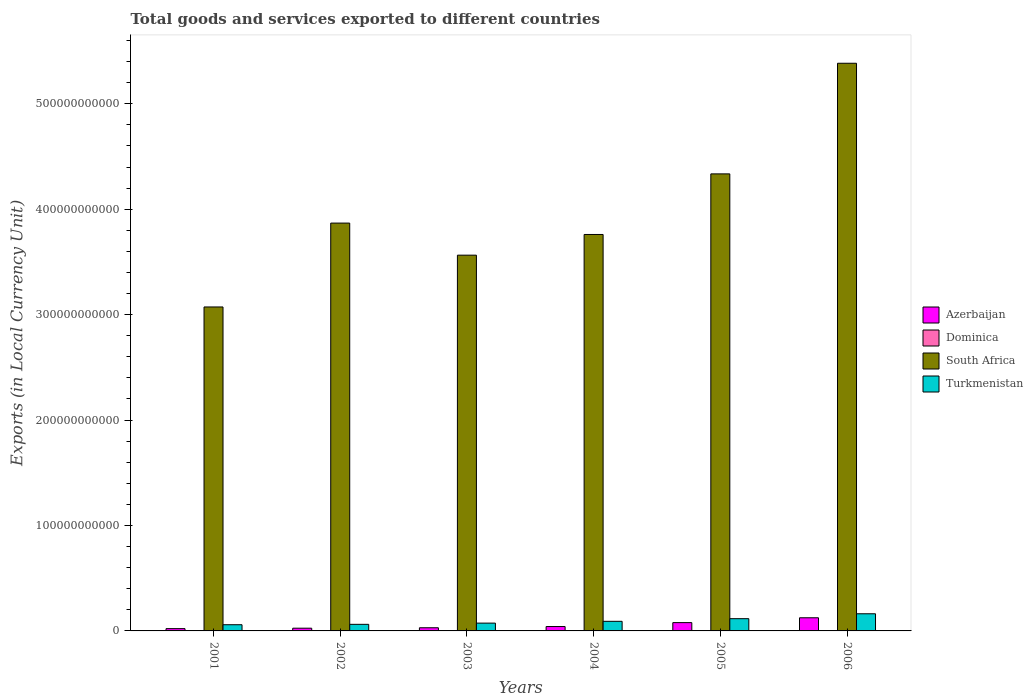How many groups of bars are there?
Make the answer very short. 6. How many bars are there on the 4th tick from the right?
Keep it short and to the point. 4. What is the label of the 6th group of bars from the left?
Keep it short and to the point. 2006. What is the Amount of goods and services exports in Azerbaijan in 2004?
Give a very brief answer. 4.16e+09. Across all years, what is the maximum Amount of goods and services exports in Azerbaijan?
Your answer should be compact. 1.25e+1. Across all years, what is the minimum Amount of goods and services exports in Azerbaijan?
Offer a terse response. 2.18e+09. In which year was the Amount of goods and services exports in Azerbaijan minimum?
Your response must be concise. 2001. What is the total Amount of goods and services exports in Azerbaijan in the graph?
Provide a succinct answer. 3.23e+1. What is the difference between the Amount of goods and services exports in Turkmenistan in 2002 and that in 2003?
Give a very brief answer. -1.16e+09. What is the difference between the Amount of goods and services exports in South Africa in 2005 and the Amount of goods and services exports in Azerbaijan in 2001?
Ensure brevity in your answer.  4.31e+11. What is the average Amount of goods and services exports in Azerbaijan per year?
Ensure brevity in your answer.  5.38e+09. In the year 2006, what is the difference between the Amount of goods and services exports in Dominica and Amount of goods and services exports in South Africa?
Make the answer very short. -5.38e+11. In how many years, is the Amount of goods and services exports in Turkmenistan greater than 260000000000 LCU?
Your answer should be compact. 0. What is the ratio of the Amount of goods and services exports in Azerbaijan in 2002 to that in 2005?
Offer a terse response. 0.33. Is the Amount of goods and services exports in Dominica in 2001 less than that in 2004?
Ensure brevity in your answer.  Yes. What is the difference between the highest and the second highest Amount of goods and services exports in Turkmenistan?
Your answer should be very brief. 4.65e+09. What is the difference between the highest and the lowest Amount of goods and services exports in Turkmenistan?
Give a very brief answer. 1.04e+1. Is it the case that in every year, the sum of the Amount of goods and services exports in South Africa and Amount of goods and services exports in Azerbaijan is greater than the sum of Amount of goods and services exports in Turkmenistan and Amount of goods and services exports in Dominica?
Your response must be concise. No. What does the 4th bar from the left in 2004 represents?
Your answer should be compact. Turkmenistan. What does the 1st bar from the right in 2003 represents?
Your response must be concise. Turkmenistan. Is it the case that in every year, the sum of the Amount of goods and services exports in Dominica and Amount of goods and services exports in Turkmenistan is greater than the Amount of goods and services exports in South Africa?
Provide a succinct answer. No. Are all the bars in the graph horizontal?
Provide a succinct answer. No. How many years are there in the graph?
Offer a very short reply. 6. What is the difference between two consecutive major ticks on the Y-axis?
Provide a short and direct response. 1.00e+11. Are the values on the major ticks of Y-axis written in scientific E-notation?
Make the answer very short. No. Does the graph contain any zero values?
Make the answer very short. No. Where does the legend appear in the graph?
Your answer should be compact. Center right. What is the title of the graph?
Keep it short and to the point. Total goods and services exported to different countries. Does "Congo (Republic)" appear as one of the legend labels in the graph?
Make the answer very short. No. What is the label or title of the X-axis?
Keep it short and to the point. Years. What is the label or title of the Y-axis?
Keep it short and to the point. Exports (in Local Currency Unit). What is the Exports (in Local Currency Unit) in Azerbaijan in 2001?
Offer a terse response. 2.18e+09. What is the Exports (in Local Currency Unit) in Dominica in 2001?
Offer a terse response. 3.27e+08. What is the Exports (in Local Currency Unit) of South Africa in 2001?
Keep it short and to the point. 3.07e+11. What is the Exports (in Local Currency Unit) in Turkmenistan in 2001?
Offer a very short reply. 5.87e+09. What is the Exports (in Local Currency Unit) of Azerbaijan in 2002?
Offer a terse response. 2.59e+09. What is the Exports (in Local Currency Unit) in Dominica in 2002?
Ensure brevity in your answer.  3.33e+08. What is the Exports (in Local Currency Unit) in South Africa in 2002?
Your answer should be compact. 3.87e+11. What is the Exports (in Local Currency Unit) in Turkmenistan in 2002?
Your response must be concise. 6.25e+09. What is the Exports (in Local Currency Unit) in Azerbaijan in 2003?
Ensure brevity in your answer.  3.00e+09. What is the Exports (in Local Currency Unit) of Dominica in 2003?
Provide a short and direct response. 3.20e+08. What is the Exports (in Local Currency Unit) in South Africa in 2003?
Offer a terse response. 3.56e+11. What is the Exports (in Local Currency Unit) in Turkmenistan in 2003?
Keep it short and to the point. 7.40e+09. What is the Exports (in Local Currency Unit) of Azerbaijan in 2004?
Keep it short and to the point. 4.16e+09. What is the Exports (in Local Currency Unit) of Dominica in 2004?
Offer a very short reply. 3.52e+08. What is the Exports (in Local Currency Unit) in South Africa in 2004?
Offer a very short reply. 3.76e+11. What is the Exports (in Local Currency Unit) of Turkmenistan in 2004?
Your answer should be very brief. 9.10e+09. What is the Exports (in Local Currency Unit) of Azerbaijan in 2005?
Your response must be concise. 7.88e+09. What is the Exports (in Local Currency Unit) in Dominica in 2005?
Your response must be concise. 3.49e+08. What is the Exports (in Local Currency Unit) in South Africa in 2005?
Keep it short and to the point. 4.34e+11. What is the Exports (in Local Currency Unit) of Turkmenistan in 2005?
Offer a very short reply. 1.16e+1. What is the Exports (in Local Currency Unit) in Azerbaijan in 2006?
Provide a short and direct response. 1.25e+1. What is the Exports (in Local Currency Unit) in Dominica in 2006?
Provide a succinct answer. 3.90e+08. What is the Exports (in Local Currency Unit) of South Africa in 2006?
Your answer should be compact. 5.38e+11. What is the Exports (in Local Currency Unit) of Turkmenistan in 2006?
Your response must be concise. 1.63e+1. Across all years, what is the maximum Exports (in Local Currency Unit) in Azerbaijan?
Your answer should be very brief. 1.25e+1. Across all years, what is the maximum Exports (in Local Currency Unit) in Dominica?
Offer a terse response. 3.90e+08. Across all years, what is the maximum Exports (in Local Currency Unit) of South Africa?
Keep it short and to the point. 5.38e+11. Across all years, what is the maximum Exports (in Local Currency Unit) of Turkmenistan?
Keep it short and to the point. 1.63e+1. Across all years, what is the minimum Exports (in Local Currency Unit) in Azerbaijan?
Give a very brief answer. 2.18e+09. Across all years, what is the minimum Exports (in Local Currency Unit) of Dominica?
Offer a very short reply. 3.20e+08. Across all years, what is the minimum Exports (in Local Currency Unit) of South Africa?
Make the answer very short. 3.07e+11. Across all years, what is the minimum Exports (in Local Currency Unit) in Turkmenistan?
Offer a terse response. 5.87e+09. What is the total Exports (in Local Currency Unit) in Azerbaijan in the graph?
Provide a succinct answer. 3.23e+1. What is the total Exports (in Local Currency Unit) in Dominica in the graph?
Your response must be concise. 2.07e+09. What is the total Exports (in Local Currency Unit) of South Africa in the graph?
Your response must be concise. 2.40e+12. What is the total Exports (in Local Currency Unit) in Turkmenistan in the graph?
Keep it short and to the point. 5.65e+1. What is the difference between the Exports (in Local Currency Unit) in Azerbaijan in 2001 and that in 2002?
Offer a very short reply. -4.18e+08. What is the difference between the Exports (in Local Currency Unit) in Dominica in 2001 and that in 2002?
Your response must be concise. -5.18e+06. What is the difference between the Exports (in Local Currency Unit) of South Africa in 2001 and that in 2002?
Provide a succinct answer. -7.96e+1. What is the difference between the Exports (in Local Currency Unit) in Turkmenistan in 2001 and that in 2002?
Offer a very short reply. -3.78e+08. What is the difference between the Exports (in Local Currency Unit) of Azerbaijan in 2001 and that in 2003?
Ensure brevity in your answer.  -8.27e+08. What is the difference between the Exports (in Local Currency Unit) of Dominica in 2001 and that in 2003?
Your answer should be very brief. 7.66e+06. What is the difference between the Exports (in Local Currency Unit) in South Africa in 2001 and that in 2003?
Give a very brief answer. -4.91e+1. What is the difference between the Exports (in Local Currency Unit) in Turkmenistan in 2001 and that in 2003?
Your answer should be very brief. -1.53e+09. What is the difference between the Exports (in Local Currency Unit) of Azerbaijan in 2001 and that in 2004?
Make the answer very short. -1.99e+09. What is the difference between the Exports (in Local Currency Unit) in Dominica in 2001 and that in 2004?
Your answer should be compact. -2.49e+07. What is the difference between the Exports (in Local Currency Unit) in South Africa in 2001 and that in 2004?
Offer a terse response. -6.88e+1. What is the difference between the Exports (in Local Currency Unit) in Turkmenistan in 2001 and that in 2004?
Your answer should be very brief. -3.23e+09. What is the difference between the Exports (in Local Currency Unit) of Azerbaijan in 2001 and that in 2005?
Keep it short and to the point. -5.71e+09. What is the difference between the Exports (in Local Currency Unit) in Dominica in 2001 and that in 2005?
Your answer should be very brief. -2.16e+07. What is the difference between the Exports (in Local Currency Unit) of South Africa in 2001 and that in 2005?
Ensure brevity in your answer.  -1.26e+11. What is the difference between the Exports (in Local Currency Unit) of Turkmenistan in 2001 and that in 2005?
Make the answer very short. -5.75e+09. What is the difference between the Exports (in Local Currency Unit) of Azerbaijan in 2001 and that in 2006?
Offer a very short reply. -1.03e+1. What is the difference between the Exports (in Local Currency Unit) in Dominica in 2001 and that in 2006?
Keep it short and to the point. -6.26e+07. What is the difference between the Exports (in Local Currency Unit) of South Africa in 2001 and that in 2006?
Your answer should be compact. -2.31e+11. What is the difference between the Exports (in Local Currency Unit) of Turkmenistan in 2001 and that in 2006?
Make the answer very short. -1.04e+1. What is the difference between the Exports (in Local Currency Unit) in Azerbaijan in 2002 and that in 2003?
Provide a short and direct response. -4.09e+08. What is the difference between the Exports (in Local Currency Unit) in Dominica in 2002 and that in 2003?
Offer a terse response. 1.28e+07. What is the difference between the Exports (in Local Currency Unit) in South Africa in 2002 and that in 2003?
Ensure brevity in your answer.  3.04e+1. What is the difference between the Exports (in Local Currency Unit) in Turkmenistan in 2002 and that in 2003?
Provide a succinct answer. -1.16e+09. What is the difference between the Exports (in Local Currency Unit) of Azerbaijan in 2002 and that in 2004?
Your answer should be very brief. -1.57e+09. What is the difference between the Exports (in Local Currency Unit) in Dominica in 2002 and that in 2004?
Your answer should be very brief. -1.97e+07. What is the difference between the Exports (in Local Currency Unit) in South Africa in 2002 and that in 2004?
Offer a very short reply. 1.08e+1. What is the difference between the Exports (in Local Currency Unit) in Turkmenistan in 2002 and that in 2004?
Keep it short and to the point. -2.85e+09. What is the difference between the Exports (in Local Currency Unit) of Azerbaijan in 2002 and that in 2005?
Your answer should be compact. -5.29e+09. What is the difference between the Exports (in Local Currency Unit) of Dominica in 2002 and that in 2005?
Ensure brevity in your answer.  -1.64e+07. What is the difference between the Exports (in Local Currency Unit) of South Africa in 2002 and that in 2005?
Provide a succinct answer. -4.67e+1. What is the difference between the Exports (in Local Currency Unit) in Turkmenistan in 2002 and that in 2005?
Provide a short and direct response. -5.37e+09. What is the difference between the Exports (in Local Currency Unit) in Azerbaijan in 2002 and that in 2006?
Provide a succinct answer. -9.87e+09. What is the difference between the Exports (in Local Currency Unit) of Dominica in 2002 and that in 2006?
Make the answer very short. -5.74e+07. What is the difference between the Exports (in Local Currency Unit) in South Africa in 2002 and that in 2006?
Offer a very short reply. -1.52e+11. What is the difference between the Exports (in Local Currency Unit) in Turkmenistan in 2002 and that in 2006?
Offer a terse response. -1.00e+1. What is the difference between the Exports (in Local Currency Unit) of Azerbaijan in 2003 and that in 2004?
Your response must be concise. -1.16e+09. What is the difference between the Exports (in Local Currency Unit) in Dominica in 2003 and that in 2004?
Provide a succinct answer. -3.26e+07. What is the difference between the Exports (in Local Currency Unit) in South Africa in 2003 and that in 2004?
Give a very brief answer. -1.96e+1. What is the difference between the Exports (in Local Currency Unit) in Turkmenistan in 2003 and that in 2004?
Keep it short and to the point. -1.70e+09. What is the difference between the Exports (in Local Currency Unit) in Azerbaijan in 2003 and that in 2005?
Your answer should be compact. -4.88e+09. What is the difference between the Exports (in Local Currency Unit) in Dominica in 2003 and that in 2005?
Offer a very short reply. -2.93e+07. What is the difference between the Exports (in Local Currency Unit) of South Africa in 2003 and that in 2005?
Ensure brevity in your answer.  -7.71e+1. What is the difference between the Exports (in Local Currency Unit) of Turkmenistan in 2003 and that in 2005?
Ensure brevity in your answer.  -4.21e+09. What is the difference between the Exports (in Local Currency Unit) in Azerbaijan in 2003 and that in 2006?
Keep it short and to the point. -9.47e+09. What is the difference between the Exports (in Local Currency Unit) of Dominica in 2003 and that in 2006?
Your response must be concise. -7.03e+07. What is the difference between the Exports (in Local Currency Unit) in South Africa in 2003 and that in 2006?
Make the answer very short. -1.82e+11. What is the difference between the Exports (in Local Currency Unit) of Turkmenistan in 2003 and that in 2006?
Your response must be concise. -8.86e+09. What is the difference between the Exports (in Local Currency Unit) in Azerbaijan in 2004 and that in 2005?
Provide a succinct answer. -3.72e+09. What is the difference between the Exports (in Local Currency Unit) in Dominica in 2004 and that in 2005?
Make the answer very short. 3.29e+06. What is the difference between the Exports (in Local Currency Unit) of South Africa in 2004 and that in 2005?
Your answer should be very brief. -5.75e+1. What is the difference between the Exports (in Local Currency Unit) of Turkmenistan in 2004 and that in 2005?
Your response must be concise. -2.51e+09. What is the difference between the Exports (in Local Currency Unit) in Azerbaijan in 2004 and that in 2006?
Provide a short and direct response. -8.31e+09. What is the difference between the Exports (in Local Currency Unit) of Dominica in 2004 and that in 2006?
Provide a short and direct response. -3.77e+07. What is the difference between the Exports (in Local Currency Unit) of South Africa in 2004 and that in 2006?
Offer a terse response. -1.62e+11. What is the difference between the Exports (in Local Currency Unit) in Turkmenistan in 2004 and that in 2006?
Your response must be concise. -7.16e+09. What is the difference between the Exports (in Local Currency Unit) in Azerbaijan in 2005 and that in 2006?
Your response must be concise. -4.59e+09. What is the difference between the Exports (in Local Currency Unit) of Dominica in 2005 and that in 2006?
Ensure brevity in your answer.  -4.10e+07. What is the difference between the Exports (in Local Currency Unit) in South Africa in 2005 and that in 2006?
Provide a succinct answer. -1.05e+11. What is the difference between the Exports (in Local Currency Unit) of Turkmenistan in 2005 and that in 2006?
Your answer should be compact. -4.65e+09. What is the difference between the Exports (in Local Currency Unit) of Azerbaijan in 2001 and the Exports (in Local Currency Unit) of Dominica in 2002?
Offer a terse response. 1.84e+09. What is the difference between the Exports (in Local Currency Unit) in Azerbaijan in 2001 and the Exports (in Local Currency Unit) in South Africa in 2002?
Offer a terse response. -3.85e+11. What is the difference between the Exports (in Local Currency Unit) in Azerbaijan in 2001 and the Exports (in Local Currency Unit) in Turkmenistan in 2002?
Make the answer very short. -4.07e+09. What is the difference between the Exports (in Local Currency Unit) of Dominica in 2001 and the Exports (in Local Currency Unit) of South Africa in 2002?
Keep it short and to the point. -3.87e+11. What is the difference between the Exports (in Local Currency Unit) of Dominica in 2001 and the Exports (in Local Currency Unit) of Turkmenistan in 2002?
Give a very brief answer. -5.92e+09. What is the difference between the Exports (in Local Currency Unit) of South Africa in 2001 and the Exports (in Local Currency Unit) of Turkmenistan in 2002?
Offer a terse response. 3.01e+11. What is the difference between the Exports (in Local Currency Unit) of Azerbaijan in 2001 and the Exports (in Local Currency Unit) of Dominica in 2003?
Keep it short and to the point. 1.86e+09. What is the difference between the Exports (in Local Currency Unit) of Azerbaijan in 2001 and the Exports (in Local Currency Unit) of South Africa in 2003?
Your answer should be compact. -3.54e+11. What is the difference between the Exports (in Local Currency Unit) of Azerbaijan in 2001 and the Exports (in Local Currency Unit) of Turkmenistan in 2003?
Provide a short and direct response. -5.23e+09. What is the difference between the Exports (in Local Currency Unit) of Dominica in 2001 and the Exports (in Local Currency Unit) of South Africa in 2003?
Give a very brief answer. -3.56e+11. What is the difference between the Exports (in Local Currency Unit) of Dominica in 2001 and the Exports (in Local Currency Unit) of Turkmenistan in 2003?
Offer a very short reply. -7.08e+09. What is the difference between the Exports (in Local Currency Unit) in South Africa in 2001 and the Exports (in Local Currency Unit) in Turkmenistan in 2003?
Offer a terse response. 3.00e+11. What is the difference between the Exports (in Local Currency Unit) in Azerbaijan in 2001 and the Exports (in Local Currency Unit) in Dominica in 2004?
Keep it short and to the point. 1.82e+09. What is the difference between the Exports (in Local Currency Unit) in Azerbaijan in 2001 and the Exports (in Local Currency Unit) in South Africa in 2004?
Give a very brief answer. -3.74e+11. What is the difference between the Exports (in Local Currency Unit) in Azerbaijan in 2001 and the Exports (in Local Currency Unit) in Turkmenistan in 2004?
Make the answer very short. -6.93e+09. What is the difference between the Exports (in Local Currency Unit) of Dominica in 2001 and the Exports (in Local Currency Unit) of South Africa in 2004?
Provide a succinct answer. -3.76e+11. What is the difference between the Exports (in Local Currency Unit) of Dominica in 2001 and the Exports (in Local Currency Unit) of Turkmenistan in 2004?
Your answer should be compact. -8.77e+09. What is the difference between the Exports (in Local Currency Unit) of South Africa in 2001 and the Exports (in Local Currency Unit) of Turkmenistan in 2004?
Provide a succinct answer. 2.98e+11. What is the difference between the Exports (in Local Currency Unit) in Azerbaijan in 2001 and the Exports (in Local Currency Unit) in Dominica in 2005?
Provide a short and direct response. 1.83e+09. What is the difference between the Exports (in Local Currency Unit) in Azerbaijan in 2001 and the Exports (in Local Currency Unit) in South Africa in 2005?
Your answer should be compact. -4.31e+11. What is the difference between the Exports (in Local Currency Unit) in Azerbaijan in 2001 and the Exports (in Local Currency Unit) in Turkmenistan in 2005?
Provide a short and direct response. -9.44e+09. What is the difference between the Exports (in Local Currency Unit) of Dominica in 2001 and the Exports (in Local Currency Unit) of South Africa in 2005?
Provide a succinct answer. -4.33e+11. What is the difference between the Exports (in Local Currency Unit) of Dominica in 2001 and the Exports (in Local Currency Unit) of Turkmenistan in 2005?
Offer a very short reply. -1.13e+1. What is the difference between the Exports (in Local Currency Unit) of South Africa in 2001 and the Exports (in Local Currency Unit) of Turkmenistan in 2005?
Keep it short and to the point. 2.96e+11. What is the difference between the Exports (in Local Currency Unit) in Azerbaijan in 2001 and the Exports (in Local Currency Unit) in Dominica in 2006?
Ensure brevity in your answer.  1.79e+09. What is the difference between the Exports (in Local Currency Unit) in Azerbaijan in 2001 and the Exports (in Local Currency Unit) in South Africa in 2006?
Provide a short and direct response. -5.36e+11. What is the difference between the Exports (in Local Currency Unit) of Azerbaijan in 2001 and the Exports (in Local Currency Unit) of Turkmenistan in 2006?
Make the answer very short. -1.41e+1. What is the difference between the Exports (in Local Currency Unit) in Dominica in 2001 and the Exports (in Local Currency Unit) in South Africa in 2006?
Provide a succinct answer. -5.38e+11. What is the difference between the Exports (in Local Currency Unit) of Dominica in 2001 and the Exports (in Local Currency Unit) of Turkmenistan in 2006?
Provide a succinct answer. -1.59e+1. What is the difference between the Exports (in Local Currency Unit) of South Africa in 2001 and the Exports (in Local Currency Unit) of Turkmenistan in 2006?
Your answer should be very brief. 2.91e+11. What is the difference between the Exports (in Local Currency Unit) in Azerbaijan in 2002 and the Exports (in Local Currency Unit) in Dominica in 2003?
Your answer should be compact. 2.27e+09. What is the difference between the Exports (in Local Currency Unit) of Azerbaijan in 2002 and the Exports (in Local Currency Unit) of South Africa in 2003?
Provide a short and direct response. -3.54e+11. What is the difference between the Exports (in Local Currency Unit) in Azerbaijan in 2002 and the Exports (in Local Currency Unit) in Turkmenistan in 2003?
Provide a short and direct response. -4.81e+09. What is the difference between the Exports (in Local Currency Unit) in Dominica in 2002 and the Exports (in Local Currency Unit) in South Africa in 2003?
Offer a very short reply. -3.56e+11. What is the difference between the Exports (in Local Currency Unit) of Dominica in 2002 and the Exports (in Local Currency Unit) of Turkmenistan in 2003?
Make the answer very short. -7.07e+09. What is the difference between the Exports (in Local Currency Unit) of South Africa in 2002 and the Exports (in Local Currency Unit) of Turkmenistan in 2003?
Your response must be concise. 3.79e+11. What is the difference between the Exports (in Local Currency Unit) in Azerbaijan in 2002 and the Exports (in Local Currency Unit) in Dominica in 2004?
Your response must be concise. 2.24e+09. What is the difference between the Exports (in Local Currency Unit) in Azerbaijan in 2002 and the Exports (in Local Currency Unit) in South Africa in 2004?
Make the answer very short. -3.73e+11. What is the difference between the Exports (in Local Currency Unit) in Azerbaijan in 2002 and the Exports (in Local Currency Unit) in Turkmenistan in 2004?
Keep it short and to the point. -6.51e+09. What is the difference between the Exports (in Local Currency Unit) in Dominica in 2002 and the Exports (in Local Currency Unit) in South Africa in 2004?
Your answer should be very brief. -3.76e+11. What is the difference between the Exports (in Local Currency Unit) in Dominica in 2002 and the Exports (in Local Currency Unit) in Turkmenistan in 2004?
Offer a terse response. -8.77e+09. What is the difference between the Exports (in Local Currency Unit) in South Africa in 2002 and the Exports (in Local Currency Unit) in Turkmenistan in 2004?
Your answer should be compact. 3.78e+11. What is the difference between the Exports (in Local Currency Unit) of Azerbaijan in 2002 and the Exports (in Local Currency Unit) of Dominica in 2005?
Your answer should be very brief. 2.24e+09. What is the difference between the Exports (in Local Currency Unit) in Azerbaijan in 2002 and the Exports (in Local Currency Unit) in South Africa in 2005?
Keep it short and to the point. -4.31e+11. What is the difference between the Exports (in Local Currency Unit) in Azerbaijan in 2002 and the Exports (in Local Currency Unit) in Turkmenistan in 2005?
Your answer should be very brief. -9.02e+09. What is the difference between the Exports (in Local Currency Unit) in Dominica in 2002 and the Exports (in Local Currency Unit) in South Africa in 2005?
Provide a short and direct response. -4.33e+11. What is the difference between the Exports (in Local Currency Unit) in Dominica in 2002 and the Exports (in Local Currency Unit) in Turkmenistan in 2005?
Offer a very short reply. -1.13e+1. What is the difference between the Exports (in Local Currency Unit) of South Africa in 2002 and the Exports (in Local Currency Unit) of Turkmenistan in 2005?
Keep it short and to the point. 3.75e+11. What is the difference between the Exports (in Local Currency Unit) in Azerbaijan in 2002 and the Exports (in Local Currency Unit) in Dominica in 2006?
Give a very brief answer. 2.20e+09. What is the difference between the Exports (in Local Currency Unit) in Azerbaijan in 2002 and the Exports (in Local Currency Unit) in South Africa in 2006?
Keep it short and to the point. -5.36e+11. What is the difference between the Exports (in Local Currency Unit) of Azerbaijan in 2002 and the Exports (in Local Currency Unit) of Turkmenistan in 2006?
Provide a succinct answer. -1.37e+1. What is the difference between the Exports (in Local Currency Unit) of Dominica in 2002 and the Exports (in Local Currency Unit) of South Africa in 2006?
Your answer should be compact. -5.38e+11. What is the difference between the Exports (in Local Currency Unit) in Dominica in 2002 and the Exports (in Local Currency Unit) in Turkmenistan in 2006?
Your answer should be compact. -1.59e+1. What is the difference between the Exports (in Local Currency Unit) of South Africa in 2002 and the Exports (in Local Currency Unit) of Turkmenistan in 2006?
Offer a very short reply. 3.71e+11. What is the difference between the Exports (in Local Currency Unit) of Azerbaijan in 2003 and the Exports (in Local Currency Unit) of Dominica in 2004?
Keep it short and to the point. 2.65e+09. What is the difference between the Exports (in Local Currency Unit) of Azerbaijan in 2003 and the Exports (in Local Currency Unit) of South Africa in 2004?
Provide a succinct answer. -3.73e+11. What is the difference between the Exports (in Local Currency Unit) of Azerbaijan in 2003 and the Exports (in Local Currency Unit) of Turkmenistan in 2004?
Provide a succinct answer. -6.10e+09. What is the difference between the Exports (in Local Currency Unit) of Dominica in 2003 and the Exports (in Local Currency Unit) of South Africa in 2004?
Your answer should be very brief. -3.76e+11. What is the difference between the Exports (in Local Currency Unit) of Dominica in 2003 and the Exports (in Local Currency Unit) of Turkmenistan in 2004?
Make the answer very short. -8.78e+09. What is the difference between the Exports (in Local Currency Unit) in South Africa in 2003 and the Exports (in Local Currency Unit) in Turkmenistan in 2004?
Your answer should be compact. 3.47e+11. What is the difference between the Exports (in Local Currency Unit) in Azerbaijan in 2003 and the Exports (in Local Currency Unit) in Dominica in 2005?
Keep it short and to the point. 2.65e+09. What is the difference between the Exports (in Local Currency Unit) of Azerbaijan in 2003 and the Exports (in Local Currency Unit) of South Africa in 2005?
Offer a very short reply. -4.31e+11. What is the difference between the Exports (in Local Currency Unit) of Azerbaijan in 2003 and the Exports (in Local Currency Unit) of Turkmenistan in 2005?
Provide a succinct answer. -8.61e+09. What is the difference between the Exports (in Local Currency Unit) of Dominica in 2003 and the Exports (in Local Currency Unit) of South Africa in 2005?
Your response must be concise. -4.33e+11. What is the difference between the Exports (in Local Currency Unit) of Dominica in 2003 and the Exports (in Local Currency Unit) of Turkmenistan in 2005?
Your response must be concise. -1.13e+1. What is the difference between the Exports (in Local Currency Unit) in South Africa in 2003 and the Exports (in Local Currency Unit) in Turkmenistan in 2005?
Offer a terse response. 3.45e+11. What is the difference between the Exports (in Local Currency Unit) of Azerbaijan in 2003 and the Exports (in Local Currency Unit) of Dominica in 2006?
Provide a succinct answer. 2.61e+09. What is the difference between the Exports (in Local Currency Unit) of Azerbaijan in 2003 and the Exports (in Local Currency Unit) of South Africa in 2006?
Your answer should be very brief. -5.35e+11. What is the difference between the Exports (in Local Currency Unit) in Azerbaijan in 2003 and the Exports (in Local Currency Unit) in Turkmenistan in 2006?
Provide a succinct answer. -1.33e+1. What is the difference between the Exports (in Local Currency Unit) in Dominica in 2003 and the Exports (in Local Currency Unit) in South Africa in 2006?
Your response must be concise. -5.38e+11. What is the difference between the Exports (in Local Currency Unit) of Dominica in 2003 and the Exports (in Local Currency Unit) of Turkmenistan in 2006?
Provide a succinct answer. -1.59e+1. What is the difference between the Exports (in Local Currency Unit) in South Africa in 2003 and the Exports (in Local Currency Unit) in Turkmenistan in 2006?
Provide a succinct answer. 3.40e+11. What is the difference between the Exports (in Local Currency Unit) of Azerbaijan in 2004 and the Exports (in Local Currency Unit) of Dominica in 2005?
Make the answer very short. 3.81e+09. What is the difference between the Exports (in Local Currency Unit) in Azerbaijan in 2004 and the Exports (in Local Currency Unit) in South Africa in 2005?
Make the answer very short. -4.29e+11. What is the difference between the Exports (in Local Currency Unit) in Azerbaijan in 2004 and the Exports (in Local Currency Unit) in Turkmenistan in 2005?
Offer a very short reply. -7.45e+09. What is the difference between the Exports (in Local Currency Unit) of Dominica in 2004 and the Exports (in Local Currency Unit) of South Africa in 2005?
Make the answer very short. -4.33e+11. What is the difference between the Exports (in Local Currency Unit) of Dominica in 2004 and the Exports (in Local Currency Unit) of Turkmenistan in 2005?
Your answer should be compact. -1.13e+1. What is the difference between the Exports (in Local Currency Unit) in South Africa in 2004 and the Exports (in Local Currency Unit) in Turkmenistan in 2005?
Make the answer very short. 3.64e+11. What is the difference between the Exports (in Local Currency Unit) of Azerbaijan in 2004 and the Exports (in Local Currency Unit) of Dominica in 2006?
Ensure brevity in your answer.  3.77e+09. What is the difference between the Exports (in Local Currency Unit) in Azerbaijan in 2004 and the Exports (in Local Currency Unit) in South Africa in 2006?
Your response must be concise. -5.34e+11. What is the difference between the Exports (in Local Currency Unit) of Azerbaijan in 2004 and the Exports (in Local Currency Unit) of Turkmenistan in 2006?
Make the answer very short. -1.21e+1. What is the difference between the Exports (in Local Currency Unit) of Dominica in 2004 and the Exports (in Local Currency Unit) of South Africa in 2006?
Offer a very short reply. -5.38e+11. What is the difference between the Exports (in Local Currency Unit) in Dominica in 2004 and the Exports (in Local Currency Unit) in Turkmenistan in 2006?
Your response must be concise. -1.59e+1. What is the difference between the Exports (in Local Currency Unit) in South Africa in 2004 and the Exports (in Local Currency Unit) in Turkmenistan in 2006?
Provide a succinct answer. 3.60e+11. What is the difference between the Exports (in Local Currency Unit) of Azerbaijan in 2005 and the Exports (in Local Currency Unit) of Dominica in 2006?
Offer a very short reply. 7.49e+09. What is the difference between the Exports (in Local Currency Unit) in Azerbaijan in 2005 and the Exports (in Local Currency Unit) in South Africa in 2006?
Ensure brevity in your answer.  -5.31e+11. What is the difference between the Exports (in Local Currency Unit) of Azerbaijan in 2005 and the Exports (in Local Currency Unit) of Turkmenistan in 2006?
Make the answer very short. -8.38e+09. What is the difference between the Exports (in Local Currency Unit) of Dominica in 2005 and the Exports (in Local Currency Unit) of South Africa in 2006?
Ensure brevity in your answer.  -5.38e+11. What is the difference between the Exports (in Local Currency Unit) of Dominica in 2005 and the Exports (in Local Currency Unit) of Turkmenistan in 2006?
Keep it short and to the point. -1.59e+1. What is the difference between the Exports (in Local Currency Unit) of South Africa in 2005 and the Exports (in Local Currency Unit) of Turkmenistan in 2006?
Keep it short and to the point. 4.17e+11. What is the average Exports (in Local Currency Unit) in Azerbaijan per year?
Give a very brief answer. 5.38e+09. What is the average Exports (in Local Currency Unit) in Dominica per year?
Your response must be concise. 3.45e+08. What is the average Exports (in Local Currency Unit) in South Africa per year?
Ensure brevity in your answer.  4.00e+11. What is the average Exports (in Local Currency Unit) of Turkmenistan per year?
Provide a succinct answer. 9.42e+09. In the year 2001, what is the difference between the Exports (in Local Currency Unit) in Azerbaijan and Exports (in Local Currency Unit) in Dominica?
Offer a terse response. 1.85e+09. In the year 2001, what is the difference between the Exports (in Local Currency Unit) in Azerbaijan and Exports (in Local Currency Unit) in South Africa?
Make the answer very short. -3.05e+11. In the year 2001, what is the difference between the Exports (in Local Currency Unit) in Azerbaijan and Exports (in Local Currency Unit) in Turkmenistan?
Provide a succinct answer. -3.69e+09. In the year 2001, what is the difference between the Exports (in Local Currency Unit) in Dominica and Exports (in Local Currency Unit) in South Africa?
Make the answer very short. -3.07e+11. In the year 2001, what is the difference between the Exports (in Local Currency Unit) in Dominica and Exports (in Local Currency Unit) in Turkmenistan?
Your answer should be compact. -5.54e+09. In the year 2001, what is the difference between the Exports (in Local Currency Unit) of South Africa and Exports (in Local Currency Unit) of Turkmenistan?
Provide a short and direct response. 3.01e+11. In the year 2002, what is the difference between the Exports (in Local Currency Unit) of Azerbaijan and Exports (in Local Currency Unit) of Dominica?
Your answer should be very brief. 2.26e+09. In the year 2002, what is the difference between the Exports (in Local Currency Unit) of Azerbaijan and Exports (in Local Currency Unit) of South Africa?
Your response must be concise. -3.84e+11. In the year 2002, what is the difference between the Exports (in Local Currency Unit) of Azerbaijan and Exports (in Local Currency Unit) of Turkmenistan?
Keep it short and to the point. -3.65e+09. In the year 2002, what is the difference between the Exports (in Local Currency Unit) of Dominica and Exports (in Local Currency Unit) of South Africa?
Provide a succinct answer. -3.87e+11. In the year 2002, what is the difference between the Exports (in Local Currency Unit) of Dominica and Exports (in Local Currency Unit) of Turkmenistan?
Your answer should be compact. -5.92e+09. In the year 2002, what is the difference between the Exports (in Local Currency Unit) in South Africa and Exports (in Local Currency Unit) in Turkmenistan?
Offer a very short reply. 3.81e+11. In the year 2003, what is the difference between the Exports (in Local Currency Unit) of Azerbaijan and Exports (in Local Currency Unit) of Dominica?
Your answer should be compact. 2.68e+09. In the year 2003, what is the difference between the Exports (in Local Currency Unit) of Azerbaijan and Exports (in Local Currency Unit) of South Africa?
Provide a succinct answer. -3.53e+11. In the year 2003, what is the difference between the Exports (in Local Currency Unit) in Azerbaijan and Exports (in Local Currency Unit) in Turkmenistan?
Keep it short and to the point. -4.40e+09. In the year 2003, what is the difference between the Exports (in Local Currency Unit) of Dominica and Exports (in Local Currency Unit) of South Africa?
Provide a succinct answer. -3.56e+11. In the year 2003, what is the difference between the Exports (in Local Currency Unit) in Dominica and Exports (in Local Currency Unit) in Turkmenistan?
Your response must be concise. -7.08e+09. In the year 2003, what is the difference between the Exports (in Local Currency Unit) in South Africa and Exports (in Local Currency Unit) in Turkmenistan?
Provide a succinct answer. 3.49e+11. In the year 2004, what is the difference between the Exports (in Local Currency Unit) in Azerbaijan and Exports (in Local Currency Unit) in Dominica?
Your answer should be compact. 3.81e+09. In the year 2004, what is the difference between the Exports (in Local Currency Unit) of Azerbaijan and Exports (in Local Currency Unit) of South Africa?
Your response must be concise. -3.72e+11. In the year 2004, what is the difference between the Exports (in Local Currency Unit) of Azerbaijan and Exports (in Local Currency Unit) of Turkmenistan?
Ensure brevity in your answer.  -4.94e+09. In the year 2004, what is the difference between the Exports (in Local Currency Unit) of Dominica and Exports (in Local Currency Unit) of South Africa?
Offer a very short reply. -3.76e+11. In the year 2004, what is the difference between the Exports (in Local Currency Unit) in Dominica and Exports (in Local Currency Unit) in Turkmenistan?
Your response must be concise. -8.75e+09. In the year 2004, what is the difference between the Exports (in Local Currency Unit) of South Africa and Exports (in Local Currency Unit) of Turkmenistan?
Make the answer very short. 3.67e+11. In the year 2005, what is the difference between the Exports (in Local Currency Unit) in Azerbaijan and Exports (in Local Currency Unit) in Dominica?
Your answer should be very brief. 7.53e+09. In the year 2005, what is the difference between the Exports (in Local Currency Unit) in Azerbaijan and Exports (in Local Currency Unit) in South Africa?
Make the answer very short. -4.26e+11. In the year 2005, what is the difference between the Exports (in Local Currency Unit) in Azerbaijan and Exports (in Local Currency Unit) in Turkmenistan?
Provide a succinct answer. -3.73e+09. In the year 2005, what is the difference between the Exports (in Local Currency Unit) in Dominica and Exports (in Local Currency Unit) in South Africa?
Offer a terse response. -4.33e+11. In the year 2005, what is the difference between the Exports (in Local Currency Unit) in Dominica and Exports (in Local Currency Unit) in Turkmenistan?
Provide a succinct answer. -1.13e+1. In the year 2005, what is the difference between the Exports (in Local Currency Unit) in South Africa and Exports (in Local Currency Unit) in Turkmenistan?
Keep it short and to the point. 4.22e+11. In the year 2006, what is the difference between the Exports (in Local Currency Unit) in Azerbaijan and Exports (in Local Currency Unit) in Dominica?
Keep it short and to the point. 1.21e+1. In the year 2006, what is the difference between the Exports (in Local Currency Unit) of Azerbaijan and Exports (in Local Currency Unit) of South Africa?
Your response must be concise. -5.26e+11. In the year 2006, what is the difference between the Exports (in Local Currency Unit) in Azerbaijan and Exports (in Local Currency Unit) in Turkmenistan?
Offer a very short reply. -3.80e+09. In the year 2006, what is the difference between the Exports (in Local Currency Unit) in Dominica and Exports (in Local Currency Unit) in South Africa?
Give a very brief answer. -5.38e+11. In the year 2006, what is the difference between the Exports (in Local Currency Unit) of Dominica and Exports (in Local Currency Unit) of Turkmenistan?
Provide a short and direct response. -1.59e+1. In the year 2006, what is the difference between the Exports (in Local Currency Unit) of South Africa and Exports (in Local Currency Unit) of Turkmenistan?
Give a very brief answer. 5.22e+11. What is the ratio of the Exports (in Local Currency Unit) in Azerbaijan in 2001 to that in 2002?
Your answer should be compact. 0.84. What is the ratio of the Exports (in Local Currency Unit) of Dominica in 2001 to that in 2002?
Your answer should be compact. 0.98. What is the ratio of the Exports (in Local Currency Unit) in South Africa in 2001 to that in 2002?
Your answer should be compact. 0.79. What is the ratio of the Exports (in Local Currency Unit) of Turkmenistan in 2001 to that in 2002?
Offer a very short reply. 0.94. What is the ratio of the Exports (in Local Currency Unit) of Azerbaijan in 2001 to that in 2003?
Offer a very short reply. 0.72. What is the ratio of the Exports (in Local Currency Unit) in Dominica in 2001 to that in 2003?
Offer a very short reply. 1.02. What is the ratio of the Exports (in Local Currency Unit) in South Africa in 2001 to that in 2003?
Give a very brief answer. 0.86. What is the ratio of the Exports (in Local Currency Unit) in Turkmenistan in 2001 to that in 2003?
Your answer should be compact. 0.79. What is the ratio of the Exports (in Local Currency Unit) in Azerbaijan in 2001 to that in 2004?
Provide a short and direct response. 0.52. What is the ratio of the Exports (in Local Currency Unit) of Dominica in 2001 to that in 2004?
Provide a short and direct response. 0.93. What is the ratio of the Exports (in Local Currency Unit) in South Africa in 2001 to that in 2004?
Ensure brevity in your answer.  0.82. What is the ratio of the Exports (in Local Currency Unit) of Turkmenistan in 2001 to that in 2004?
Your response must be concise. 0.64. What is the ratio of the Exports (in Local Currency Unit) of Azerbaijan in 2001 to that in 2005?
Your response must be concise. 0.28. What is the ratio of the Exports (in Local Currency Unit) of Dominica in 2001 to that in 2005?
Keep it short and to the point. 0.94. What is the ratio of the Exports (in Local Currency Unit) of South Africa in 2001 to that in 2005?
Give a very brief answer. 0.71. What is the ratio of the Exports (in Local Currency Unit) of Turkmenistan in 2001 to that in 2005?
Offer a very short reply. 0.51. What is the ratio of the Exports (in Local Currency Unit) of Azerbaijan in 2001 to that in 2006?
Make the answer very short. 0.17. What is the ratio of the Exports (in Local Currency Unit) of Dominica in 2001 to that in 2006?
Your response must be concise. 0.84. What is the ratio of the Exports (in Local Currency Unit) of South Africa in 2001 to that in 2006?
Provide a short and direct response. 0.57. What is the ratio of the Exports (in Local Currency Unit) of Turkmenistan in 2001 to that in 2006?
Make the answer very short. 0.36. What is the ratio of the Exports (in Local Currency Unit) of Azerbaijan in 2002 to that in 2003?
Your answer should be compact. 0.86. What is the ratio of the Exports (in Local Currency Unit) in Dominica in 2002 to that in 2003?
Offer a very short reply. 1.04. What is the ratio of the Exports (in Local Currency Unit) in South Africa in 2002 to that in 2003?
Provide a short and direct response. 1.09. What is the ratio of the Exports (in Local Currency Unit) of Turkmenistan in 2002 to that in 2003?
Make the answer very short. 0.84. What is the ratio of the Exports (in Local Currency Unit) of Azerbaijan in 2002 to that in 2004?
Your response must be concise. 0.62. What is the ratio of the Exports (in Local Currency Unit) in Dominica in 2002 to that in 2004?
Provide a short and direct response. 0.94. What is the ratio of the Exports (in Local Currency Unit) of South Africa in 2002 to that in 2004?
Your answer should be compact. 1.03. What is the ratio of the Exports (in Local Currency Unit) of Turkmenistan in 2002 to that in 2004?
Offer a very short reply. 0.69. What is the ratio of the Exports (in Local Currency Unit) of Azerbaijan in 2002 to that in 2005?
Your answer should be compact. 0.33. What is the ratio of the Exports (in Local Currency Unit) of Dominica in 2002 to that in 2005?
Your answer should be compact. 0.95. What is the ratio of the Exports (in Local Currency Unit) in South Africa in 2002 to that in 2005?
Give a very brief answer. 0.89. What is the ratio of the Exports (in Local Currency Unit) of Turkmenistan in 2002 to that in 2005?
Provide a short and direct response. 0.54. What is the ratio of the Exports (in Local Currency Unit) of Azerbaijan in 2002 to that in 2006?
Give a very brief answer. 0.21. What is the ratio of the Exports (in Local Currency Unit) of Dominica in 2002 to that in 2006?
Ensure brevity in your answer.  0.85. What is the ratio of the Exports (in Local Currency Unit) in South Africa in 2002 to that in 2006?
Offer a terse response. 0.72. What is the ratio of the Exports (in Local Currency Unit) of Turkmenistan in 2002 to that in 2006?
Your answer should be very brief. 0.38. What is the ratio of the Exports (in Local Currency Unit) in Azerbaijan in 2003 to that in 2004?
Keep it short and to the point. 0.72. What is the ratio of the Exports (in Local Currency Unit) of Dominica in 2003 to that in 2004?
Ensure brevity in your answer.  0.91. What is the ratio of the Exports (in Local Currency Unit) of South Africa in 2003 to that in 2004?
Your response must be concise. 0.95. What is the ratio of the Exports (in Local Currency Unit) of Turkmenistan in 2003 to that in 2004?
Offer a very short reply. 0.81. What is the ratio of the Exports (in Local Currency Unit) in Azerbaijan in 2003 to that in 2005?
Your answer should be compact. 0.38. What is the ratio of the Exports (in Local Currency Unit) in Dominica in 2003 to that in 2005?
Ensure brevity in your answer.  0.92. What is the ratio of the Exports (in Local Currency Unit) in South Africa in 2003 to that in 2005?
Ensure brevity in your answer.  0.82. What is the ratio of the Exports (in Local Currency Unit) in Turkmenistan in 2003 to that in 2005?
Your answer should be compact. 0.64. What is the ratio of the Exports (in Local Currency Unit) in Azerbaijan in 2003 to that in 2006?
Make the answer very short. 0.24. What is the ratio of the Exports (in Local Currency Unit) in Dominica in 2003 to that in 2006?
Your response must be concise. 0.82. What is the ratio of the Exports (in Local Currency Unit) in South Africa in 2003 to that in 2006?
Ensure brevity in your answer.  0.66. What is the ratio of the Exports (in Local Currency Unit) in Turkmenistan in 2003 to that in 2006?
Provide a short and direct response. 0.46. What is the ratio of the Exports (in Local Currency Unit) in Azerbaijan in 2004 to that in 2005?
Provide a succinct answer. 0.53. What is the ratio of the Exports (in Local Currency Unit) of Dominica in 2004 to that in 2005?
Your response must be concise. 1.01. What is the ratio of the Exports (in Local Currency Unit) of South Africa in 2004 to that in 2005?
Offer a very short reply. 0.87. What is the ratio of the Exports (in Local Currency Unit) of Turkmenistan in 2004 to that in 2005?
Offer a terse response. 0.78. What is the ratio of the Exports (in Local Currency Unit) of Azerbaijan in 2004 to that in 2006?
Offer a terse response. 0.33. What is the ratio of the Exports (in Local Currency Unit) in Dominica in 2004 to that in 2006?
Provide a short and direct response. 0.9. What is the ratio of the Exports (in Local Currency Unit) in South Africa in 2004 to that in 2006?
Make the answer very short. 0.7. What is the ratio of the Exports (in Local Currency Unit) of Turkmenistan in 2004 to that in 2006?
Keep it short and to the point. 0.56. What is the ratio of the Exports (in Local Currency Unit) of Azerbaijan in 2005 to that in 2006?
Your answer should be compact. 0.63. What is the ratio of the Exports (in Local Currency Unit) in Dominica in 2005 to that in 2006?
Ensure brevity in your answer.  0.89. What is the ratio of the Exports (in Local Currency Unit) of South Africa in 2005 to that in 2006?
Provide a short and direct response. 0.81. What is the ratio of the Exports (in Local Currency Unit) in Turkmenistan in 2005 to that in 2006?
Your answer should be very brief. 0.71. What is the difference between the highest and the second highest Exports (in Local Currency Unit) in Azerbaijan?
Provide a succinct answer. 4.59e+09. What is the difference between the highest and the second highest Exports (in Local Currency Unit) of Dominica?
Your answer should be very brief. 3.77e+07. What is the difference between the highest and the second highest Exports (in Local Currency Unit) in South Africa?
Offer a very short reply. 1.05e+11. What is the difference between the highest and the second highest Exports (in Local Currency Unit) in Turkmenistan?
Your answer should be compact. 4.65e+09. What is the difference between the highest and the lowest Exports (in Local Currency Unit) in Azerbaijan?
Offer a terse response. 1.03e+1. What is the difference between the highest and the lowest Exports (in Local Currency Unit) of Dominica?
Provide a short and direct response. 7.03e+07. What is the difference between the highest and the lowest Exports (in Local Currency Unit) of South Africa?
Keep it short and to the point. 2.31e+11. What is the difference between the highest and the lowest Exports (in Local Currency Unit) in Turkmenistan?
Provide a short and direct response. 1.04e+1. 